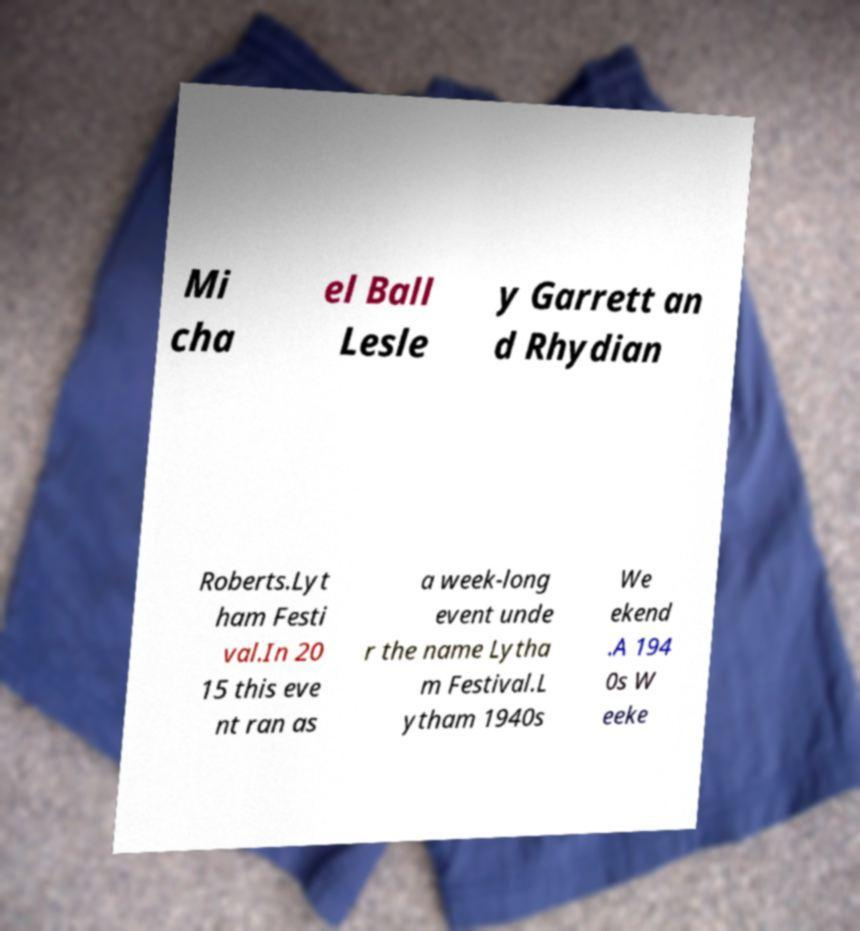Could you assist in decoding the text presented in this image and type it out clearly? Mi cha el Ball Lesle y Garrett an d Rhydian Roberts.Lyt ham Festi val.In 20 15 this eve nt ran as a week-long event unde r the name Lytha m Festival.L ytham 1940s We ekend .A 194 0s W eeke 